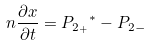Convert formula to latex. <formula><loc_0><loc_0><loc_500><loc_500>n \frac { \partial x } { \partial t } = { P _ { 2 _ { + } } } ^ { * } - P _ { 2 - }</formula> 